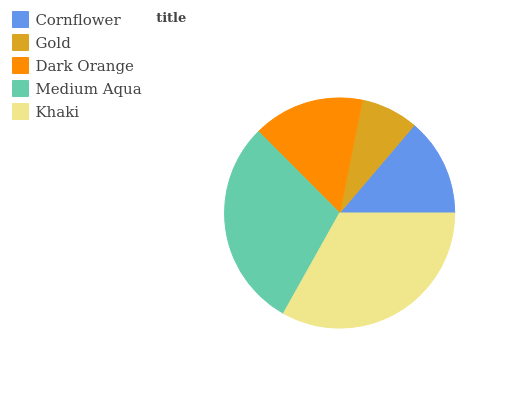Is Gold the minimum?
Answer yes or no. Yes. Is Khaki the maximum?
Answer yes or no. Yes. Is Dark Orange the minimum?
Answer yes or no. No. Is Dark Orange the maximum?
Answer yes or no. No. Is Dark Orange greater than Gold?
Answer yes or no. Yes. Is Gold less than Dark Orange?
Answer yes or no. Yes. Is Gold greater than Dark Orange?
Answer yes or no. No. Is Dark Orange less than Gold?
Answer yes or no. No. Is Dark Orange the high median?
Answer yes or no. Yes. Is Dark Orange the low median?
Answer yes or no. Yes. Is Medium Aqua the high median?
Answer yes or no. No. Is Gold the low median?
Answer yes or no. No. 